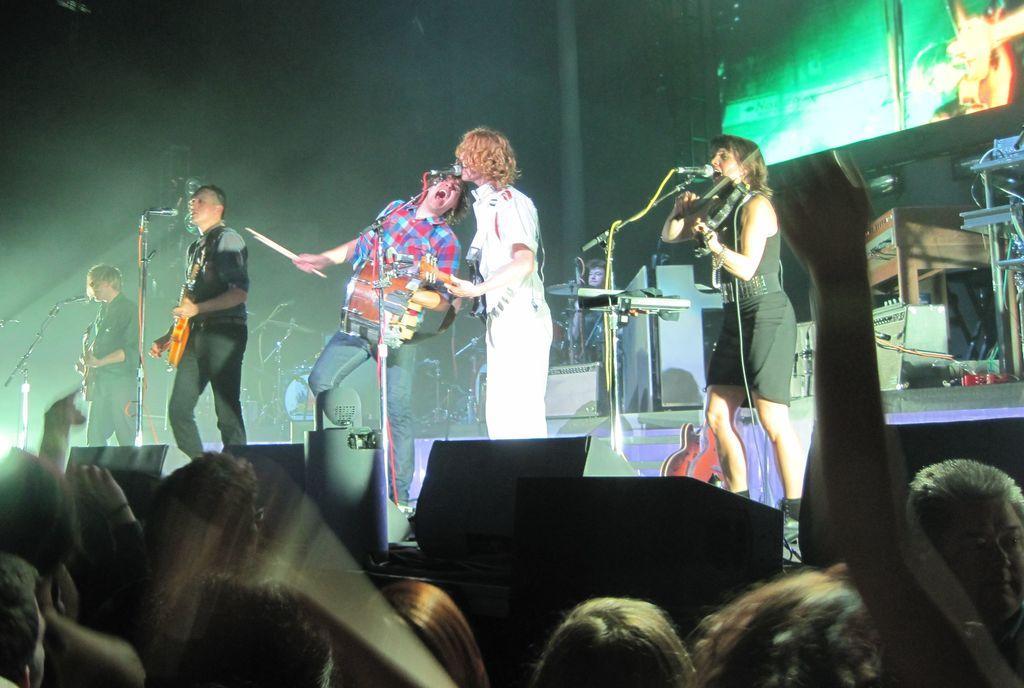How would you summarize this image in a sentence or two? In this image i can see number of people down the stage, on the stage i can see few people standing and holding musical instruments and their hands. I can see microphones in front of them. In the background i can see few musical instruments and the screen. 